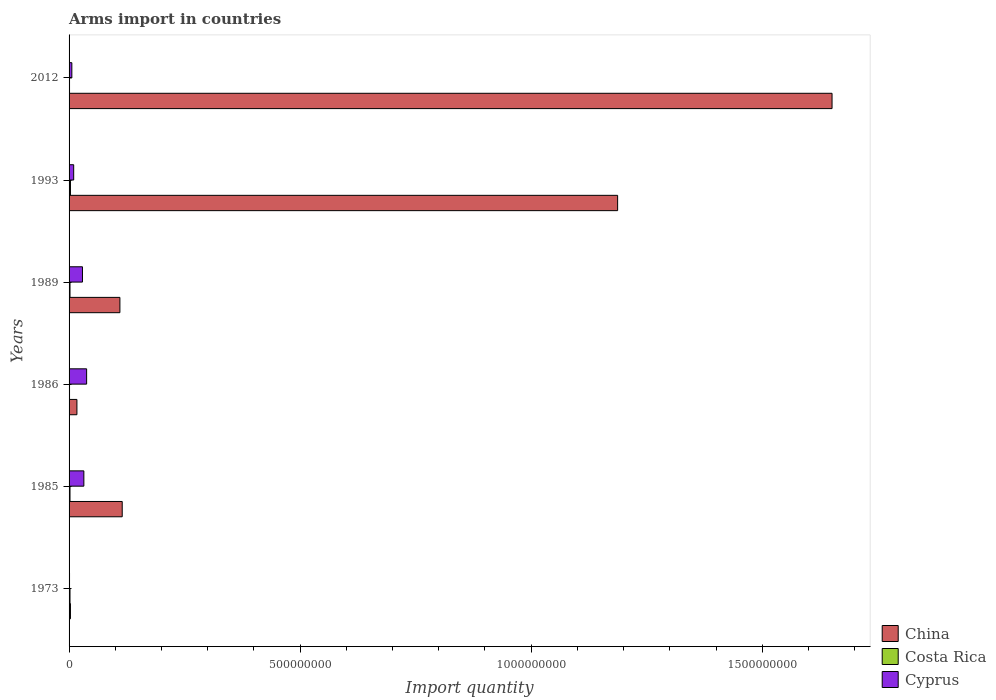Are the number of bars per tick equal to the number of legend labels?
Keep it short and to the point. Yes. Are the number of bars on each tick of the Y-axis equal?
Offer a very short reply. Yes. How many bars are there on the 2nd tick from the top?
Provide a short and direct response. 3. What is the label of the 6th group of bars from the top?
Make the answer very short. 1973. In how many cases, is the number of bars for a given year not equal to the number of legend labels?
Offer a very short reply. 0. What is the total arms import in Costa Rica in 1993?
Ensure brevity in your answer.  3.00e+06. Across all years, what is the maximum total arms import in China?
Offer a terse response. 1.65e+09. Across all years, what is the minimum total arms import in China?
Give a very brief answer. 3.00e+06. In which year was the total arms import in Cyprus maximum?
Your answer should be compact. 1986. What is the total total arms import in China in the graph?
Make the answer very short. 3.08e+09. What is the difference between the total arms import in Cyprus in 1985 and that in 1986?
Make the answer very short. -6.00e+06. What is the difference between the total arms import in China in 1993 and the total arms import in Costa Rica in 2012?
Make the answer very short. 1.19e+09. What is the average total arms import in Costa Rica per year?
Your response must be concise. 1.83e+06. In the year 2012, what is the difference between the total arms import in China and total arms import in Cyprus?
Your response must be concise. 1.64e+09. What is the ratio of the total arms import in Costa Rica in 1985 to that in 2012?
Offer a terse response. 2. Is the difference between the total arms import in China in 1986 and 2012 greater than the difference between the total arms import in Cyprus in 1986 and 2012?
Provide a short and direct response. No. What is the difference between the highest and the lowest total arms import in China?
Give a very brief answer. 1.65e+09. In how many years, is the total arms import in Costa Rica greater than the average total arms import in Costa Rica taken over all years?
Provide a short and direct response. 4. What does the 2nd bar from the top in 1989 represents?
Your response must be concise. Costa Rica. What does the 3rd bar from the bottom in 2012 represents?
Provide a short and direct response. Cyprus. How many bars are there?
Provide a succinct answer. 18. Are all the bars in the graph horizontal?
Make the answer very short. Yes. How many years are there in the graph?
Provide a short and direct response. 6. What is the difference between two consecutive major ticks on the X-axis?
Offer a very short reply. 5.00e+08. Are the values on the major ticks of X-axis written in scientific E-notation?
Your answer should be very brief. No. Does the graph contain grids?
Keep it short and to the point. No. Where does the legend appear in the graph?
Make the answer very short. Bottom right. How many legend labels are there?
Offer a terse response. 3. What is the title of the graph?
Ensure brevity in your answer.  Arms import in countries. Does "Heavily indebted poor countries" appear as one of the legend labels in the graph?
Ensure brevity in your answer.  No. What is the label or title of the X-axis?
Offer a terse response. Import quantity. What is the Import quantity of China in 1973?
Your response must be concise. 3.00e+06. What is the Import quantity in Costa Rica in 1973?
Offer a very short reply. 2.00e+06. What is the Import quantity of Cyprus in 1973?
Ensure brevity in your answer.  1.00e+06. What is the Import quantity in China in 1985?
Provide a succinct answer. 1.15e+08. What is the Import quantity in Cyprus in 1985?
Offer a terse response. 3.20e+07. What is the Import quantity in China in 1986?
Keep it short and to the point. 1.70e+07. What is the Import quantity of Cyprus in 1986?
Ensure brevity in your answer.  3.80e+07. What is the Import quantity of China in 1989?
Offer a terse response. 1.10e+08. What is the Import quantity in Cyprus in 1989?
Make the answer very short. 2.90e+07. What is the Import quantity of China in 1993?
Make the answer very short. 1.19e+09. What is the Import quantity of Cyprus in 1993?
Your answer should be compact. 1.00e+07. What is the Import quantity in China in 2012?
Your answer should be very brief. 1.65e+09. What is the Import quantity of Costa Rica in 2012?
Make the answer very short. 1.00e+06. What is the Import quantity in Cyprus in 2012?
Provide a short and direct response. 6.00e+06. Across all years, what is the maximum Import quantity in China?
Offer a terse response. 1.65e+09. Across all years, what is the maximum Import quantity in Cyprus?
Make the answer very short. 3.80e+07. Across all years, what is the minimum Import quantity of Costa Rica?
Your response must be concise. 1.00e+06. What is the total Import quantity of China in the graph?
Offer a terse response. 3.08e+09. What is the total Import quantity in Costa Rica in the graph?
Keep it short and to the point. 1.10e+07. What is the total Import quantity in Cyprus in the graph?
Ensure brevity in your answer.  1.16e+08. What is the difference between the Import quantity of China in 1973 and that in 1985?
Keep it short and to the point. -1.12e+08. What is the difference between the Import quantity in Costa Rica in 1973 and that in 1985?
Keep it short and to the point. 0. What is the difference between the Import quantity of Cyprus in 1973 and that in 1985?
Offer a very short reply. -3.10e+07. What is the difference between the Import quantity of China in 1973 and that in 1986?
Provide a succinct answer. -1.40e+07. What is the difference between the Import quantity in Cyprus in 1973 and that in 1986?
Ensure brevity in your answer.  -3.70e+07. What is the difference between the Import quantity of China in 1973 and that in 1989?
Keep it short and to the point. -1.07e+08. What is the difference between the Import quantity in Costa Rica in 1973 and that in 1989?
Offer a terse response. 0. What is the difference between the Import quantity in Cyprus in 1973 and that in 1989?
Ensure brevity in your answer.  -2.80e+07. What is the difference between the Import quantity in China in 1973 and that in 1993?
Give a very brief answer. -1.18e+09. What is the difference between the Import quantity in Costa Rica in 1973 and that in 1993?
Offer a very short reply. -1.00e+06. What is the difference between the Import quantity of Cyprus in 1973 and that in 1993?
Keep it short and to the point. -9.00e+06. What is the difference between the Import quantity of China in 1973 and that in 2012?
Ensure brevity in your answer.  -1.65e+09. What is the difference between the Import quantity of Cyprus in 1973 and that in 2012?
Your answer should be compact. -5.00e+06. What is the difference between the Import quantity in China in 1985 and that in 1986?
Make the answer very short. 9.80e+07. What is the difference between the Import quantity in Cyprus in 1985 and that in 1986?
Provide a succinct answer. -6.00e+06. What is the difference between the Import quantity of China in 1985 and that in 1993?
Provide a short and direct response. -1.07e+09. What is the difference between the Import quantity in Cyprus in 1985 and that in 1993?
Your response must be concise. 2.20e+07. What is the difference between the Import quantity in China in 1985 and that in 2012?
Make the answer very short. -1.54e+09. What is the difference between the Import quantity of Costa Rica in 1985 and that in 2012?
Keep it short and to the point. 1.00e+06. What is the difference between the Import quantity of Cyprus in 1985 and that in 2012?
Give a very brief answer. 2.60e+07. What is the difference between the Import quantity in China in 1986 and that in 1989?
Offer a terse response. -9.30e+07. What is the difference between the Import quantity of Cyprus in 1986 and that in 1989?
Offer a terse response. 9.00e+06. What is the difference between the Import quantity of China in 1986 and that in 1993?
Your answer should be compact. -1.17e+09. What is the difference between the Import quantity in Costa Rica in 1986 and that in 1993?
Offer a terse response. -2.00e+06. What is the difference between the Import quantity of Cyprus in 1986 and that in 1993?
Offer a very short reply. 2.80e+07. What is the difference between the Import quantity of China in 1986 and that in 2012?
Your answer should be very brief. -1.63e+09. What is the difference between the Import quantity in Costa Rica in 1986 and that in 2012?
Offer a terse response. 0. What is the difference between the Import quantity in Cyprus in 1986 and that in 2012?
Give a very brief answer. 3.20e+07. What is the difference between the Import quantity in China in 1989 and that in 1993?
Your response must be concise. -1.08e+09. What is the difference between the Import quantity in Costa Rica in 1989 and that in 1993?
Keep it short and to the point. -1.00e+06. What is the difference between the Import quantity in Cyprus in 1989 and that in 1993?
Ensure brevity in your answer.  1.90e+07. What is the difference between the Import quantity in China in 1989 and that in 2012?
Your answer should be very brief. -1.54e+09. What is the difference between the Import quantity of Costa Rica in 1989 and that in 2012?
Make the answer very short. 1.00e+06. What is the difference between the Import quantity in Cyprus in 1989 and that in 2012?
Your answer should be compact. 2.30e+07. What is the difference between the Import quantity of China in 1993 and that in 2012?
Offer a terse response. -4.64e+08. What is the difference between the Import quantity of Costa Rica in 1993 and that in 2012?
Your answer should be very brief. 2.00e+06. What is the difference between the Import quantity of China in 1973 and the Import quantity of Cyprus in 1985?
Provide a succinct answer. -2.90e+07. What is the difference between the Import quantity in Costa Rica in 1973 and the Import quantity in Cyprus in 1985?
Your response must be concise. -3.00e+07. What is the difference between the Import quantity in China in 1973 and the Import quantity in Cyprus in 1986?
Keep it short and to the point. -3.50e+07. What is the difference between the Import quantity of Costa Rica in 1973 and the Import quantity of Cyprus in 1986?
Your answer should be compact. -3.60e+07. What is the difference between the Import quantity of China in 1973 and the Import quantity of Cyprus in 1989?
Ensure brevity in your answer.  -2.60e+07. What is the difference between the Import quantity in Costa Rica in 1973 and the Import quantity in Cyprus in 1989?
Offer a very short reply. -2.70e+07. What is the difference between the Import quantity in China in 1973 and the Import quantity in Cyprus in 1993?
Provide a short and direct response. -7.00e+06. What is the difference between the Import quantity in Costa Rica in 1973 and the Import quantity in Cyprus in 1993?
Make the answer very short. -8.00e+06. What is the difference between the Import quantity in China in 1973 and the Import quantity in Cyprus in 2012?
Give a very brief answer. -3.00e+06. What is the difference between the Import quantity in Costa Rica in 1973 and the Import quantity in Cyprus in 2012?
Your answer should be compact. -4.00e+06. What is the difference between the Import quantity in China in 1985 and the Import quantity in Costa Rica in 1986?
Your answer should be very brief. 1.14e+08. What is the difference between the Import quantity of China in 1985 and the Import quantity of Cyprus in 1986?
Provide a short and direct response. 7.70e+07. What is the difference between the Import quantity of Costa Rica in 1985 and the Import quantity of Cyprus in 1986?
Ensure brevity in your answer.  -3.60e+07. What is the difference between the Import quantity of China in 1985 and the Import quantity of Costa Rica in 1989?
Your answer should be very brief. 1.13e+08. What is the difference between the Import quantity in China in 1985 and the Import quantity in Cyprus in 1989?
Provide a succinct answer. 8.60e+07. What is the difference between the Import quantity in Costa Rica in 1985 and the Import quantity in Cyprus in 1989?
Offer a very short reply. -2.70e+07. What is the difference between the Import quantity in China in 1985 and the Import quantity in Costa Rica in 1993?
Give a very brief answer. 1.12e+08. What is the difference between the Import quantity in China in 1985 and the Import quantity in Cyprus in 1993?
Give a very brief answer. 1.05e+08. What is the difference between the Import quantity of Costa Rica in 1985 and the Import quantity of Cyprus in 1993?
Make the answer very short. -8.00e+06. What is the difference between the Import quantity of China in 1985 and the Import quantity of Costa Rica in 2012?
Your response must be concise. 1.14e+08. What is the difference between the Import quantity of China in 1985 and the Import quantity of Cyprus in 2012?
Provide a short and direct response. 1.09e+08. What is the difference between the Import quantity of China in 1986 and the Import quantity of Costa Rica in 1989?
Provide a short and direct response. 1.50e+07. What is the difference between the Import quantity in China in 1986 and the Import quantity in Cyprus in 1989?
Give a very brief answer. -1.20e+07. What is the difference between the Import quantity in Costa Rica in 1986 and the Import quantity in Cyprus in 1989?
Provide a succinct answer. -2.80e+07. What is the difference between the Import quantity in China in 1986 and the Import quantity in Costa Rica in 1993?
Provide a succinct answer. 1.40e+07. What is the difference between the Import quantity of Costa Rica in 1986 and the Import quantity of Cyprus in 1993?
Your answer should be very brief. -9.00e+06. What is the difference between the Import quantity in China in 1986 and the Import quantity in Costa Rica in 2012?
Offer a very short reply. 1.60e+07. What is the difference between the Import quantity of China in 1986 and the Import quantity of Cyprus in 2012?
Provide a short and direct response. 1.10e+07. What is the difference between the Import quantity of Costa Rica in 1986 and the Import quantity of Cyprus in 2012?
Your answer should be compact. -5.00e+06. What is the difference between the Import quantity in China in 1989 and the Import quantity in Costa Rica in 1993?
Give a very brief answer. 1.07e+08. What is the difference between the Import quantity of Costa Rica in 1989 and the Import quantity of Cyprus in 1993?
Your answer should be very brief. -8.00e+06. What is the difference between the Import quantity of China in 1989 and the Import quantity of Costa Rica in 2012?
Offer a very short reply. 1.09e+08. What is the difference between the Import quantity of China in 1989 and the Import quantity of Cyprus in 2012?
Offer a terse response. 1.04e+08. What is the difference between the Import quantity in China in 1993 and the Import quantity in Costa Rica in 2012?
Keep it short and to the point. 1.19e+09. What is the difference between the Import quantity in China in 1993 and the Import quantity in Cyprus in 2012?
Your response must be concise. 1.18e+09. What is the difference between the Import quantity of Costa Rica in 1993 and the Import quantity of Cyprus in 2012?
Provide a succinct answer. -3.00e+06. What is the average Import quantity of China per year?
Offer a very short reply. 5.14e+08. What is the average Import quantity in Costa Rica per year?
Ensure brevity in your answer.  1.83e+06. What is the average Import quantity of Cyprus per year?
Ensure brevity in your answer.  1.93e+07. In the year 1973, what is the difference between the Import quantity of China and Import quantity of Costa Rica?
Your answer should be compact. 1.00e+06. In the year 1973, what is the difference between the Import quantity in Costa Rica and Import quantity in Cyprus?
Make the answer very short. 1.00e+06. In the year 1985, what is the difference between the Import quantity of China and Import quantity of Costa Rica?
Keep it short and to the point. 1.13e+08. In the year 1985, what is the difference between the Import quantity of China and Import quantity of Cyprus?
Ensure brevity in your answer.  8.30e+07. In the year 1985, what is the difference between the Import quantity of Costa Rica and Import quantity of Cyprus?
Offer a very short reply. -3.00e+07. In the year 1986, what is the difference between the Import quantity of China and Import quantity of Costa Rica?
Make the answer very short. 1.60e+07. In the year 1986, what is the difference between the Import quantity in China and Import quantity in Cyprus?
Your answer should be very brief. -2.10e+07. In the year 1986, what is the difference between the Import quantity of Costa Rica and Import quantity of Cyprus?
Keep it short and to the point. -3.70e+07. In the year 1989, what is the difference between the Import quantity in China and Import quantity in Costa Rica?
Your answer should be very brief. 1.08e+08. In the year 1989, what is the difference between the Import quantity in China and Import quantity in Cyprus?
Offer a terse response. 8.10e+07. In the year 1989, what is the difference between the Import quantity of Costa Rica and Import quantity of Cyprus?
Offer a terse response. -2.70e+07. In the year 1993, what is the difference between the Import quantity in China and Import quantity in Costa Rica?
Give a very brief answer. 1.18e+09. In the year 1993, what is the difference between the Import quantity of China and Import quantity of Cyprus?
Your answer should be compact. 1.18e+09. In the year 1993, what is the difference between the Import quantity of Costa Rica and Import quantity of Cyprus?
Give a very brief answer. -7.00e+06. In the year 2012, what is the difference between the Import quantity in China and Import quantity in Costa Rica?
Give a very brief answer. 1.65e+09. In the year 2012, what is the difference between the Import quantity of China and Import quantity of Cyprus?
Provide a succinct answer. 1.64e+09. In the year 2012, what is the difference between the Import quantity of Costa Rica and Import quantity of Cyprus?
Offer a very short reply. -5.00e+06. What is the ratio of the Import quantity in China in 1973 to that in 1985?
Give a very brief answer. 0.03. What is the ratio of the Import quantity of Cyprus in 1973 to that in 1985?
Your response must be concise. 0.03. What is the ratio of the Import quantity of China in 1973 to that in 1986?
Your response must be concise. 0.18. What is the ratio of the Import quantity in Cyprus in 1973 to that in 1986?
Ensure brevity in your answer.  0.03. What is the ratio of the Import quantity of China in 1973 to that in 1989?
Your answer should be compact. 0.03. What is the ratio of the Import quantity of Cyprus in 1973 to that in 1989?
Your response must be concise. 0.03. What is the ratio of the Import quantity in China in 1973 to that in 1993?
Your answer should be very brief. 0. What is the ratio of the Import quantity in Costa Rica in 1973 to that in 1993?
Make the answer very short. 0.67. What is the ratio of the Import quantity in Cyprus in 1973 to that in 1993?
Provide a short and direct response. 0.1. What is the ratio of the Import quantity of China in 1973 to that in 2012?
Offer a terse response. 0. What is the ratio of the Import quantity of China in 1985 to that in 1986?
Provide a succinct answer. 6.76. What is the ratio of the Import quantity in Costa Rica in 1985 to that in 1986?
Keep it short and to the point. 2. What is the ratio of the Import quantity of Cyprus in 1985 to that in 1986?
Offer a terse response. 0.84. What is the ratio of the Import quantity of China in 1985 to that in 1989?
Make the answer very short. 1.05. What is the ratio of the Import quantity in Cyprus in 1985 to that in 1989?
Ensure brevity in your answer.  1.1. What is the ratio of the Import quantity in China in 1985 to that in 1993?
Offer a terse response. 0.1. What is the ratio of the Import quantity in Cyprus in 1985 to that in 1993?
Your response must be concise. 3.2. What is the ratio of the Import quantity in China in 1985 to that in 2012?
Provide a short and direct response. 0.07. What is the ratio of the Import quantity of Cyprus in 1985 to that in 2012?
Provide a succinct answer. 5.33. What is the ratio of the Import quantity in China in 1986 to that in 1989?
Provide a short and direct response. 0.15. What is the ratio of the Import quantity in Cyprus in 1986 to that in 1989?
Your answer should be very brief. 1.31. What is the ratio of the Import quantity of China in 1986 to that in 1993?
Ensure brevity in your answer.  0.01. What is the ratio of the Import quantity of Cyprus in 1986 to that in 1993?
Keep it short and to the point. 3.8. What is the ratio of the Import quantity in China in 1986 to that in 2012?
Your answer should be compact. 0.01. What is the ratio of the Import quantity of Cyprus in 1986 to that in 2012?
Give a very brief answer. 6.33. What is the ratio of the Import quantity of China in 1989 to that in 1993?
Ensure brevity in your answer.  0.09. What is the ratio of the Import quantity of Costa Rica in 1989 to that in 1993?
Keep it short and to the point. 0.67. What is the ratio of the Import quantity of Cyprus in 1989 to that in 1993?
Your answer should be very brief. 2.9. What is the ratio of the Import quantity in China in 1989 to that in 2012?
Your answer should be compact. 0.07. What is the ratio of the Import quantity in Costa Rica in 1989 to that in 2012?
Give a very brief answer. 2. What is the ratio of the Import quantity of Cyprus in 1989 to that in 2012?
Your answer should be compact. 4.83. What is the ratio of the Import quantity in China in 1993 to that in 2012?
Offer a very short reply. 0.72. What is the ratio of the Import quantity of Costa Rica in 1993 to that in 2012?
Keep it short and to the point. 3. What is the difference between the highest and the second highest Import quantity of China?
Provide a succinct answer. 4.64e+08. What is the difference between the highest and the lowest Import quantity of China?
Make the answer very short. 1.65e+09. What is the difference between the highest and the lowest Import quantity in Costa Rica?
Your response must be concise. 2.00e+06. What is the difference between the highest and the lowest Import quantity of Cyprus?
Make the answer very short. 3.70e+07. 